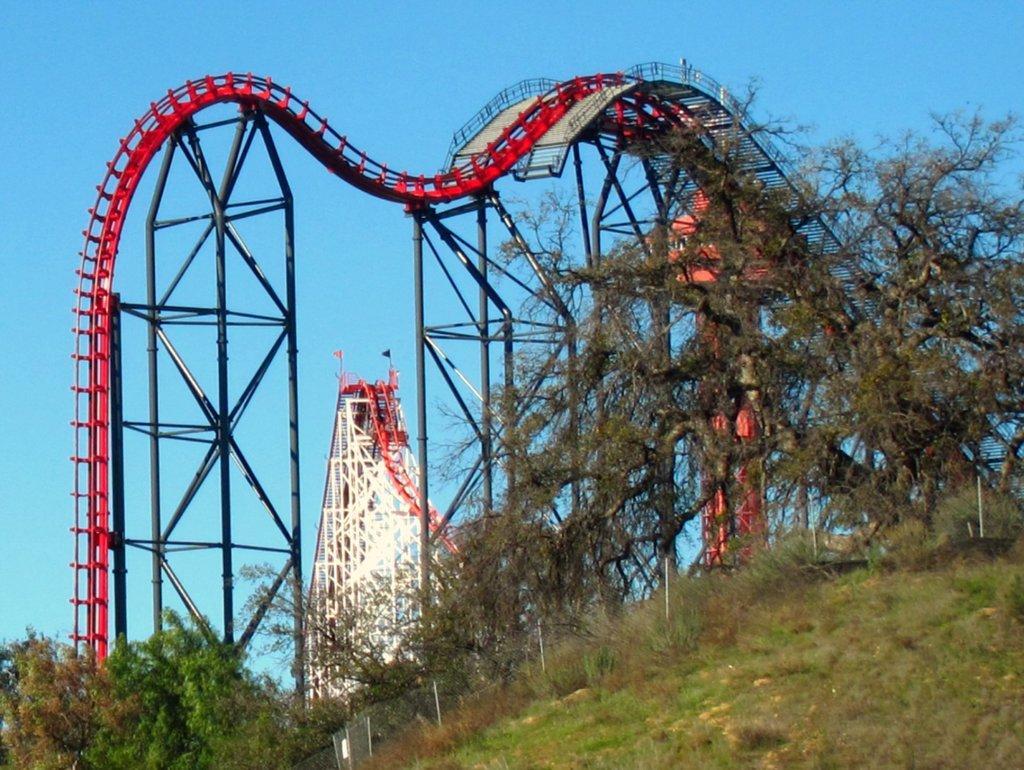Please provide a concise description of this image. In this picture i can see the rolling coaster. At the bottom i can see the trees, fencing, plants and grass. At the top there is a sky. 